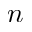Convert formula to latex. <formula><loc_0><loc_0><loc_500><loc_500>n</formula> 